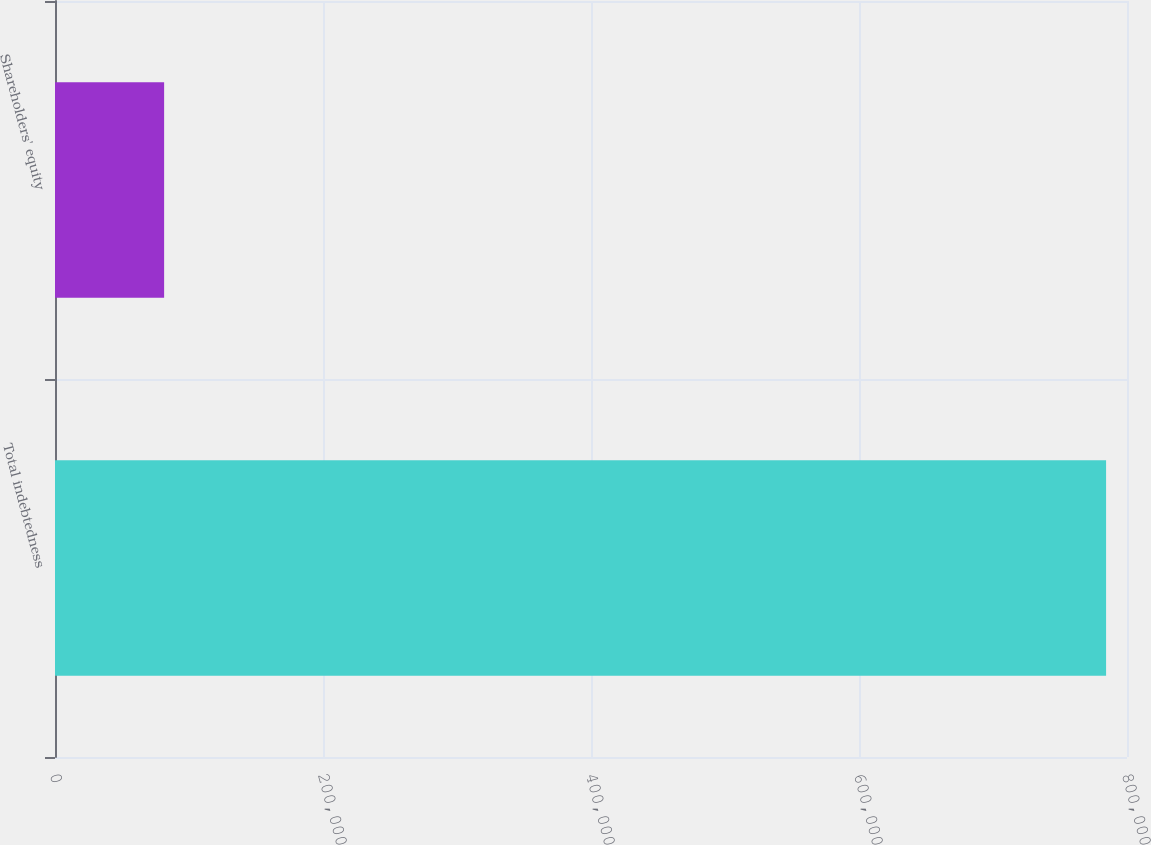Convert chart. <chart><loc_0><loc_0><loc_500><loc_500><bar_chart><fcel>Total indebtedness<fcel>Shareholders' equity<nl><fcel>784392<fcel>81431<nl></chart> 